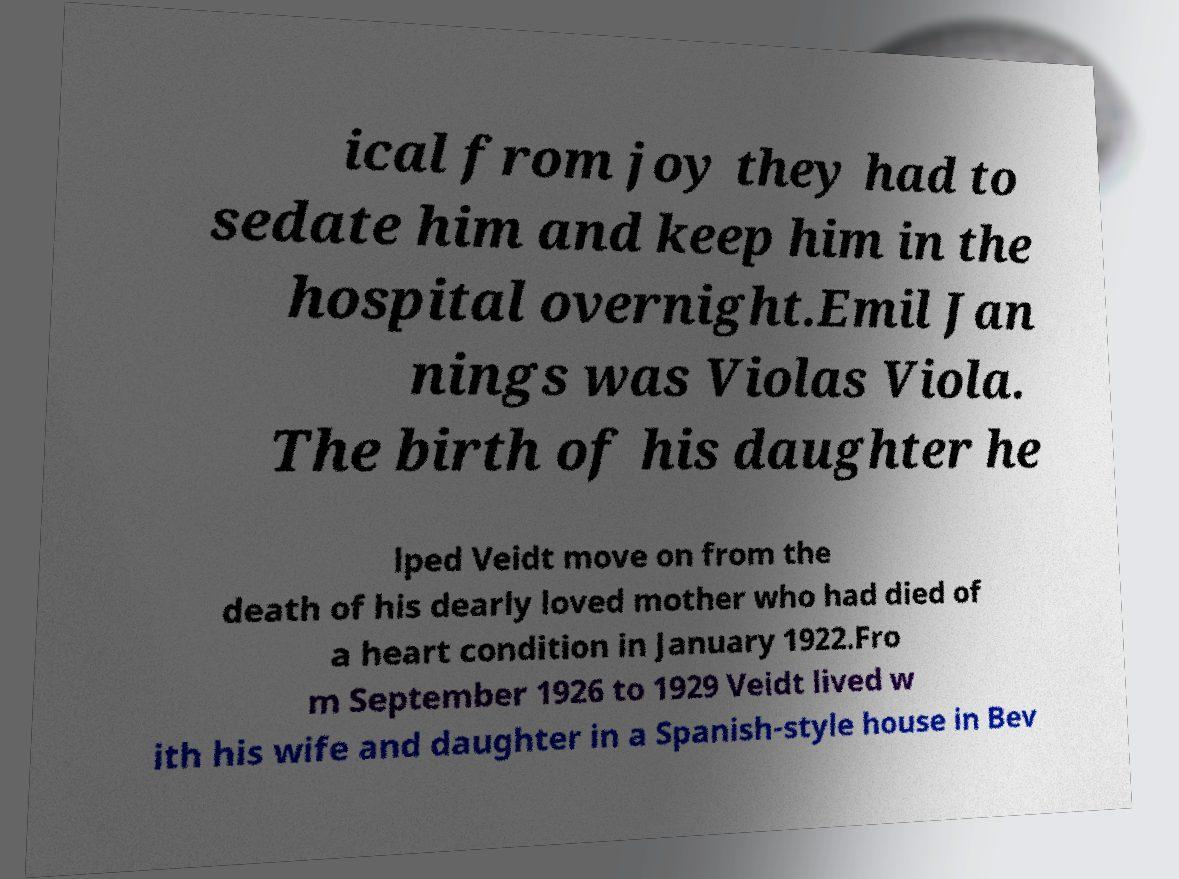There's text embedded in this image that I need extracted. Can you transcribe it verbatim? ical from joy they had to sedate him and keep him in the hospital overnight.Emil Jan nings was Violas Viola. The birth of his daughter he lped Veidt move on from the death of his dearly loved mother who had died of a heart condition in January 1922.Fro m September 1926 to 1929 Veidt lived w ith his wife and daughter in a Spanish-style house in Bev 